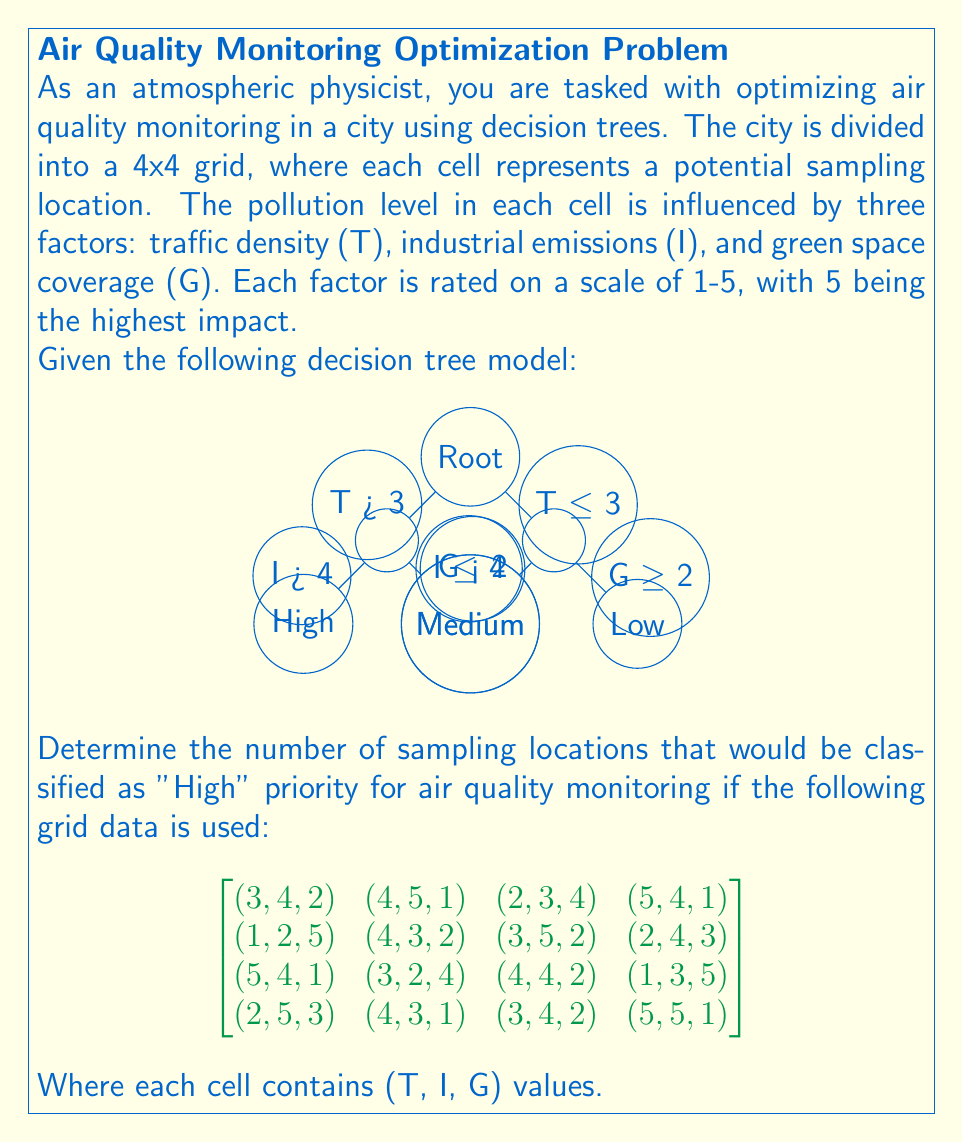Provide a solution to this math problem. To solve this problem, we need to evaluate each cell in the grid using the given decision tree. Let's go through the process step-by-step:

1. First, we'll examine the decision tree:
   - If T > 3, we move to the left branch.
   - On the left branch, if I > 4, the location is classified as "High" priority.
   - If T ≤ 3, we move to the right branch.
   - On the right branch, if G < 2, the location is classified as "Medium" priority, otherwise "Low".

2. Now, let's evaluate each cell in the grid:

Row 1:
(3,4,2): T ≤ 3, G ≥ 2 → Low
(4,5,1): T > 3, I > 4 → High
(2,3,4): T ≤ 3, G ≥ 2 → Low
(5,4,1): T > 3, I ≤ 4 → Medium

Row 2:
(1,2,5): T ≤ 3, G ≥ 2 → Low
(4,3,2): T > 3, I ≤ 4 → Medium
(3,5,2): T ≤ 3, G ≥ 2 → Low
(2,4,3): T ≤ 3, G ≥ 2 → Low

Row 3:
(5,4,1): T > 3, I ≤ 4 → Medium
(3,2,4): T ≤ 3, G ≥ 2 → Low
(4,4,2): T > 3, I ≤ 4 → Medium
(1,3,5): T ≤ 3, G ≥ 2 → Low

Row 4:
(2,5,3): T ≤ 3, G ≥ 2 → Low
(4,3,1): T > 3, I ≤ 4 → Medium
(3,4,2): T ≤ 3, G ≥ 2 → Low
(5,5,1): T > 3, I > 4 → High

3. Count the number of "High" priority locations:
   There are 2 locations classified as "High" priority.
Answer: 2 